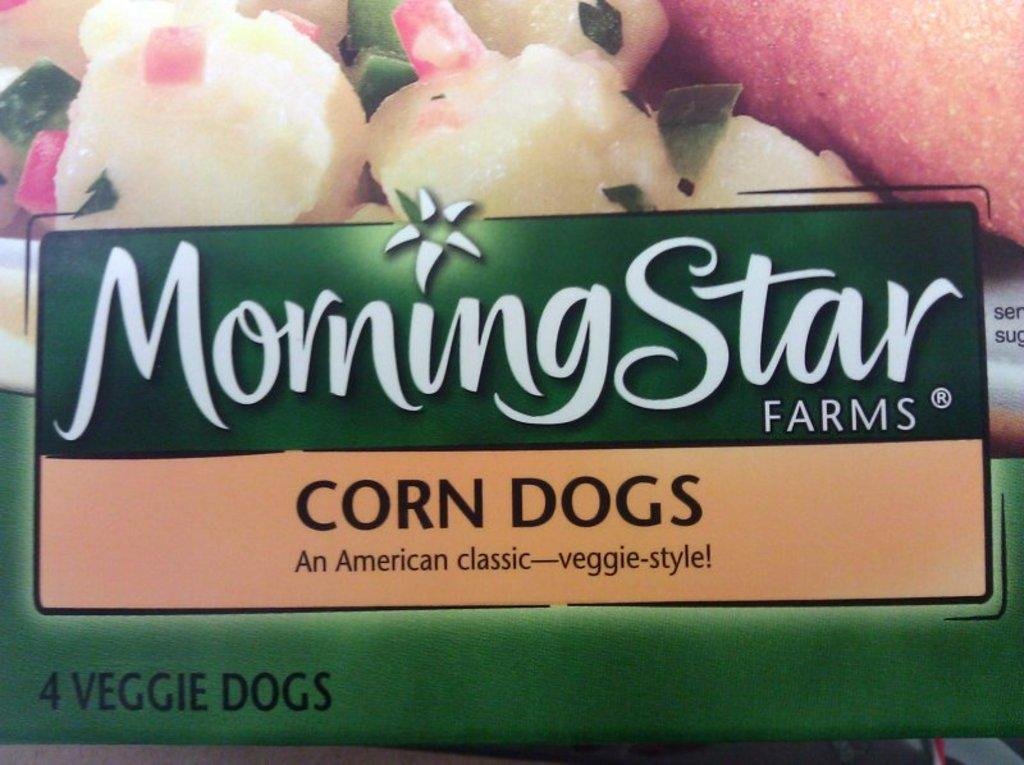What is present in the image that represents a design or symbol? There is a sticker in the image. What is shown on the sticker? The sticker depicts a food item. Is there any text on the sticker? Yes, there is text on the sticker. How does the flower on the sticker react to the earthquake in the image? There is no earthquake or flower present in the image; it only features a sticker with a food item and text. 